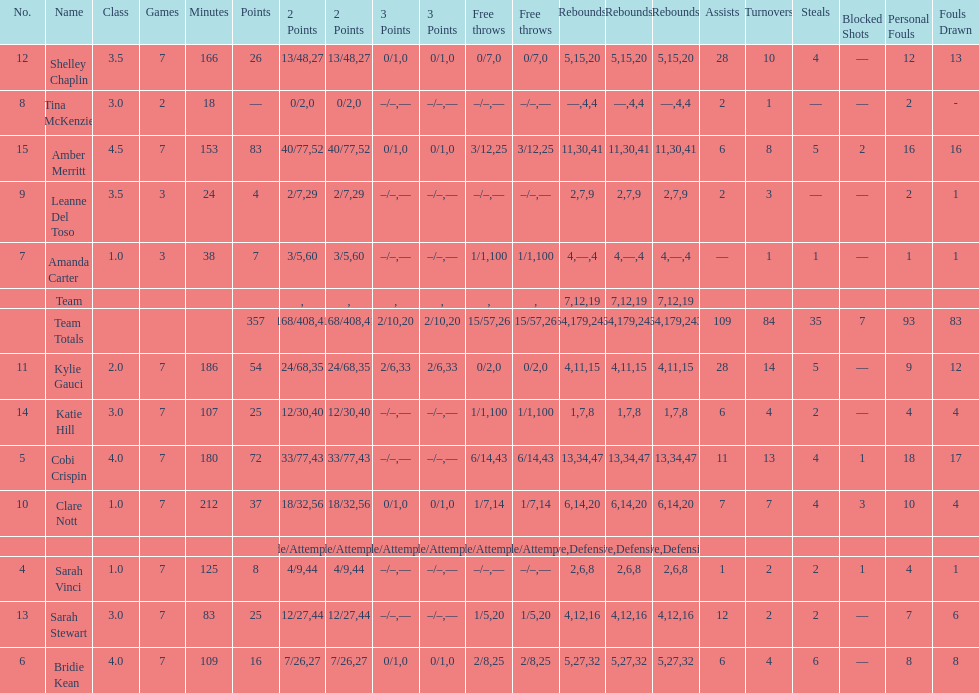Number of 3 points attempted 10. 